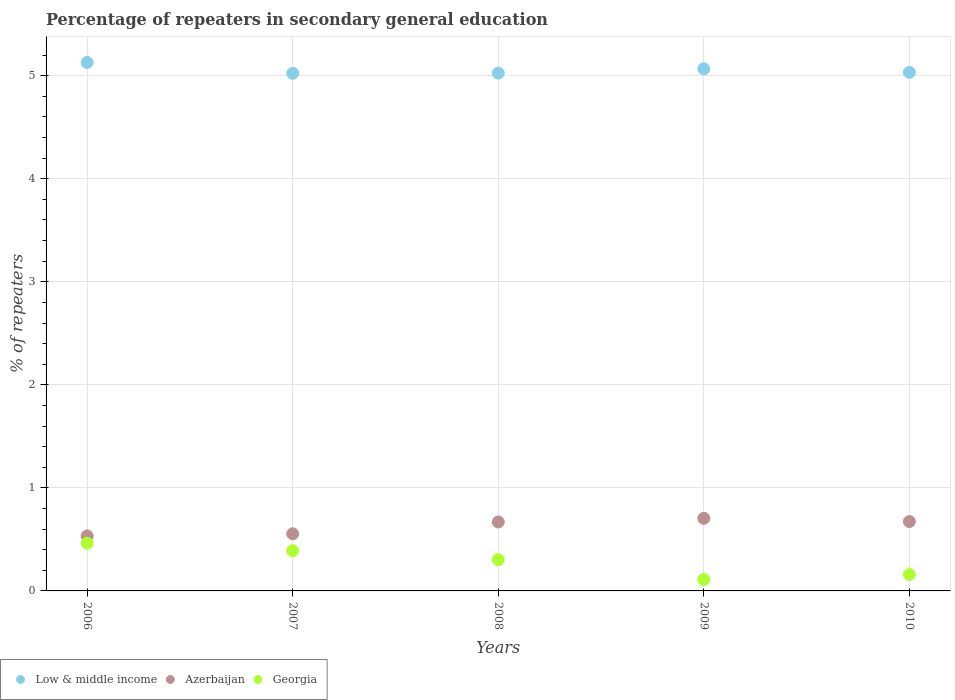How many different coloured dotlines are there?
Ensure brevity in your answer.  3. Is the number of dotlines equal to the number of legend labels?
Ensure brevity in your answer.  Yes. What is the percentage of repeaters in secondary general education in Azerbaijan in 2009?
Keep it short and to the point. 0.7. Across all years, what is the maximum percentage of repeaters in secondary general education in Georgia?
Your response must be concise. 0.46. Across all years, what is the minimum percentage of repeaters in secondary general education in Azerbaijan?
Give a very brief answer. 0.53. In which year was the percentage of repeaters in secondary general education in Georgia minimum?
Offer a very short reply. 2009. What is the total percentage of repeaters in secondary general education in Low & middle income in the graph?
Keep it short and to the point. 25.28. What is the difference between the percentage of repeaters in secondary general education in Low & middle income in 2007 and that in 2010?
Ensure brevity in your answer.  -0.01. What is the difference between the percentage of repeaters in secondary general education in Georgia in 2008 and the percentage of repeaters in secondary general education in Azerbaijan in 2007?
Your response must be concise. -0.25. What is the average percentage of repeaters in secondary general education in Low & middle income per year?
Provide a short and direct response. 5.06. In the year 2010, what is the difference between the percentage of repeaters in secondary general education in Georgia and percentage of repeaters in secondary general education in Azerbaijan?
Make the answer very short. -0.51. What is the ratio of the percentage of repeaters in secondary general education in Low & middle income in 2008 to that in 2010?
Keep it short and to the point. 1. Is the difference between the percentage of repeaters in secondary general education in Georgia in 2008 and 2009 greater than the difference between the percentage of repeaters in secondary general education in Azerbaijan in 2008 and 2009?
Make the answer very short. Yes. What is the difference between the highest and the second highest percentage of repeaters in secondary general education in Azerbaijan?
Ensure brevity in your answer.  0.03. What is the difference between the highest and the lowest percentage of repeaters in secondary general education in Georgia?
Your response must be concise. 0.35. In how many years, is the percentage of repeaters in secondary general education in Low & middle income greater than the average percentage of repeaters in secondary general education in Low & middle income taken over all years?
Give a very brief answer. 2. Is it the case that in every year, the sum of the percentage of repeaters in secondary general education in Azerbaijan and percentage of repeaters in secondary general education in Low & middle income  is greater than the percentage of repeaters in secondary general education in Georgia?
Your answer should be very brief. Yes. Does the percentage of repeaters in secondary general education in Azerbaijan monotonically increase over the years?
Provide a succinct answer. No. Is the percentage of repeaters in secondary general education in Georgia strictly less than the percentage of repeaters in secondary general education in Azerbaijan over the years?
Provide a succinct answer. Yes. How many dotlines are there?
Keep it short and to the point. 3. What is the difference between two consecutive major ticks on the Y-axis?
Offer a terse response. 1. Are the values on the major ticks of Y-axis written in scientific E-notation?
Ensure brevity in your answer.  No. Does the graph contain any zero values?
Offer a terse response. No. Where does the legend appear in the graph?
Give a very brief answer. Bottom left. How many legend labels are there?
Your answer should be compact. 3. What is the title of the graph?
Offer a terse response. Percentage of repeaters in secondary general education. What is the label or title of the X-axis?
Offer a very short reply. Years. What is the label or title of the Y-axis?
Offer a terse response. % of repeaters. What is the % of repeaters in Low & middle income in 2006?
Offer a very short reply. 5.13. What is the % of repeaters in Azerbaijan in 2006?
Your answer should be compact. 0.53. What is the % of repeaters of Georgia in 2006?
Offer a terse response. 0.46. What is the % of repeaters in Low & middle income in 2007?
Your answer should be compact. 5.02. What is the % of repeaters in Azerbaijan in 2007?
Offer a terse response. 0.55. What is the % of repeaters of Georgia in 2007?
Ensure brevity in your answer.  0.39. What is the % of repeaters in Low & middle income in 2008?
Your response must be concise. 5.02. What is the % of repeaters of Azerbaijan in 2008?
Give a very brief answer. 0.67. What is the % of repeaters in Georgia in 2008?
Your answer should be compact. 0.3. What is the % of repeaters in Low & middle income in 2009?
Ensure brevity in your answer.  5.07. What is the % of repeaters in Azerbaijan in 2009?
Make the answer very short. 0.7. What is the % of repeaters of Georgia in 2009?
Keep it short and to the point. 0.11. What is the % of repeaters of Low & middle income in 2010?
Give a very brief answer. 5.03. What is the % of repeaters of Azerbaijan in 2010?
Offer a very short reply. 0.67. What is the % of repeaters in Georgia in 2010?
Ensure brevity in your answer.  0.16. Across all years, what is the maximum % of repeaters of Low & middle income?
Offer a very short reply. 5.13. Across all years, what is the maximum % of repeaters of Azerbaijan?
Offer a very short reply. 0.7. Across all years, what is the maximum % of repeaters of Georgia?
Ensure brevity in your answer.  0.46. Across all years, what is the minimum % of repeaters of Low & middle income?
Offer a very short reply. 5.02. Across all years, what is the minimum % of repeaters of Azerbaijan?
Offer a terse response. 0.53. Across all years, what is the minimum % of repeaters in Georgia?
Give a very brief answer. 0.11. What is the total % of repeaters in Low & middle income in the graph?
Ensure brevity in your answer.  25.28. What is the total % of repeaters of Azerbaijan in the graph?
Ensure brevity in your answer.  3.14. What is the total % of repeaters of Georgia in the graph?
Your answer should be very brief. 1.43. What is the difference between the % of repeaters in Low & middle income in 2006 and that in 2007?
Your response must be concise. 0.11. What is the difference between the % of repeaters in Azerbaijan in 2006 and that in 2007?
Your answer should be compact. -0.02. What is the difference between the % of repeaters in Georgia in 2006 and that in 2007?
Make the answer very short. 0.07. What is the difference between the % of repeaters in Low & middle income in 2006 and that in 2008?
Provide a succinct answer. 0.1. What is the difference between the % of repeaters in Azerbaijan in 2006 and that in 2008?
Provide a short and direct response. -0.14. What is the difference between the % of repeaters in Georgia in 2006 and that in 2008?
Ensure brevity in your answer.  0.16. What is the difference between the % of repeaters in Low & middle income in 2006 and that in 2009?
Provide a short and direct response. 0.06. What is the difference between the % of repeaters of Azerbaijan in 2006 and that in 2009?
Offer a terse response. -0.17. What is the difference between the % of repeaters in Georgia in 2006 and that in 2009?
Make the answer very short. 0.35. What is the difference between the % of repeaters of Low & middle income in 2006 and that in 2010?
Make the answer very short. 0.1. What is the difference between the % of repeaters in Azerbaijan in 2006 and that in 2010?
Give a very brief answer. -0.14. What is the difference between the % of repeaters in Georgia in 2006 and that in 2010?
Offer a very short reply. 0.3. What is the difference between the % of repeaters in Low & middle income in 2007 and that in 2008?
Offer a terse response. -0. What is the difference between the % of repeaters of Azerbaijan in 2007 and that in 2008?
Your response must be concise. -0.11. What is the difference between the % of repeaters of Georgia in 2007 and that in 2008?
Offer a very short reply. 0.09. What is the difference between the % of repeaters of Low & middle income in 2007 and that in 2009?
Your answer should be compact. -0.04. What is the difference between the % of repeaters of Azerbaijan in 2007 and that in 2009?
Give a very brief answer. -0.15. What is the difference between the % of repeaters in Georgia in 2007 and that in 2009?
Provide a short and direct response. 0.28. What is the difference between the % of repeaters in Low & middle income in 2007 and that in 2010?
Offer a terse response. -0.01. What is the difference between the % of repeaters in Azerbaijan in 2007 and that in 2010?
Offer a terse response. -0.12. What is the difference between the % of repeaters in Georgia in 2007 and that in 2010?
Offer a terse response. 0.23. What is the difference between the % of repeaters of Low & middle income in 2008 and that in 2009?
Ensure brevity in your answer.  -0.04. What is the difference between the % of repeaters in Azerbaijan in 2008 and that in 2009?
Make the answer very short. -0.04. What is the difference between the % of repeaters of Georgia in 2008 and that in 2009?
Give a very brief answer. 0.19. What is the difference between the % of repeaters in Low & middle income in 2008 and that in 2010?
Offer a very short reply. -0.01. What is the difference between the % of repeaters of Azerbaijan in 2008 and that in 2010?
Provide a short and direct response. -0. What is the difference between the % of repeaters of Georgia in 2008 and that in 2010?
Provide a short and direct response. 0.14. What is the difference between the % of repeaters of Low & middle income in 2009 and that in 2010?
Offer a very short reply. 0.03. What is the difference between the % of repeaters of Azerbaijan in 2009 and that in 2010?
Offer a very short reply. 0.03. What is the difference between the % of repeaters of Georgia in 2009 and that in 2010?
Your answer should be compact. -0.05. What is the difference between the % of repeaters in Low & middle income in 2006 and the % of repeaters in Azerbaijan in 2007?
Provide a succinct answer. 4.57. What is the difference between the % of repeaters of Low & middle income in 2006 and the % of repeaters of Georgia in 2007?
Your answer should be compact. 4.74. What is the difference between the % of repeaters of Azerbaijan in 2006 and the % of repeaters of Georgia in 2007?
Your answer should be compact. 0.14. What is the difference between the % of repeaters in Low & middle income in 2006 and the % of repeaters in Azerbaijan in 2008?
Your answer should be very brief. 4.46. What is the difference between the % of repeaters of Low & middle income in 2006 and the % of repeaters of Georgia in 2008?
Offer a terse response. 4.83. What is the difference between the % of repeaters of Azerbaijan in 2006 and the % of repeaters of Georgia in 2008?
Your answer should be compact. 0.23. What is the difference between the % of repeaters of Low & middle income in 2006 and the % of repeaters of Azerbaijan in 2009?
Offer a terse response. 4.42. What is the difference between the % of repeaters of Low & middle income in 2006 and the % of repeaters of Georgia in 2009?
Give a very brief answer. 5.02. What is the difference between the % of repeaters in Azerbaijan in 2006 and the % of repeaters in Georgia in 2009?
Give a very brief answer. 0.42. What is the difference between the % of repeaters of Low & middle income in 2006 and the % of repeaters of Azerbaijan in 2010?
Keep it short and to the point. 4.46. What is the difference between the % of repeaters in Low & middle income in 2006 and the % of repeaters in Georgia in 2010?
Make the answer very short. 4.97. What is the difference between the % of repeaters in Azerbaijan in 2006 and the % of repeaters in Georgia in 2010?
Your answer should be compact. 0.37. What is the difference between the % of repeaters of Low & middle income in 2007 and the % of repeaters of Azerbaijan in 2008?
Make the answer very short. 4.35. What is the difference between the % of repeaters in Low & middle income in 2007 and the % of repeaters in Georgia in 2008?
Your answer should be compact. 4.72. What is the difference between the % of repeaters of Azerbaijan in 2007 and the % of repeaters of Georgia in 2008?
Keep it short and to the point. 0.25. What is the difference between the % of repeaters in Low & middle income in 2007 and the % of repeaters in Azerbaijan in 2009?
Your answer should be very brief. 4.32. What is the difference between the % of repeaters in Low & middle income in 2007 and the % of repeaters in Georgia in 2009?
Your answer should be compact. 4.91. What is the difference between the % of repeaters in Azerbaijan in 2007 and the % of repeaters in Georgia in 2009?
Your answer should be compact. 0.44. What is the difference between the % of repeaters of Low & middle income in 2007 and the % of repeaters of Azerbaijan in 2010?
Your answer should be very brief. 4.35. What is the difference between the % of repeaters in Low & middle income in 2007 and the % of repeaters in Georgia in 2010?
Your answer should be very brief. 4.86. What is the difference between the % of repeaters in Azerbaijan in 2007 and the % of repeaters in Georgia in 2010?
Keep it short and to the point. 0.4. What is the difference between the % of repeaters of Low & middle income in 2008 and the % of repeaters of Azerbaijan in 2009?
Keep it short and to the point. 4.32. What is the difference between the % of repeaters in Low & middle income in 2008 and the % of repeaters in Georgia in 2009?
Your answer should be very brief. 4.91. What is the difference between the % of repeaters of Azerbaijan in 2008 and the % of repeaters of Georgia in 2009?
Provide a short and direct response. 0.56. What is the difference between the % of repeaters in Low & middle income in 2008 and the % of repeaters in Azerbaijan in 2010?
Your answer should be compact. 4.35. What is the difference between the % of repeaters of Low & middle income in 2008 and the % of repeaters of Georgia in 2010?
Offer a terse response. 4.87. What is the difference between the % of repeaters of Azerbaijan in 2008 and the % of repeaters of Georgia in 2010?
Ensure brevity in your answer.  0.51. What is the difference between the % of repeaters of Low & middle income in 2009 and the % of repeaters of Azerbaijan in 2010?
Ensure brevity in your answer.  4.39. What is the difference between the % of repeaters in Low & middle income in 2009 and the % of repeaters in Georgia in 2010?
Give a very brief answer. 4.91. What is the difference between the % of repeaters of Azerbaijan in 2009 and the % of repeaters of Georgia in 2010?
Your answer should be very brief. 0.55. What is the average % of repeaters in Low & middle income per year?
Your answer should be compact. 5.06. What is the average % of repeaters of Azerbaijan per year?
Your answer should be compact. 0.63. What is the average % of repeaters of Georgia per year?
Offer a very short reply. 0.29. In the year 2006, what is the difference between the % of repeaters in Low & middle income and % of repeaters in Azerbaijan?
Keep it short and to the point. 4.6. In the year 2006, what is the difference between the % of repeaters of Low & middle income and % of repeaters of Georgia?
Provide a short and direct response. 4.67. In the year 2006, what is the difference between the % of repeaters of Azerbaijan and % of repeaters of Georgia?
Provide a succinct answer. 0.07. In the year 2007, what is the difference between the % of repeaters of Low & middle income and % of repeaters of Azerbaijan?
Make the answer very short. 4.47. In the year 2007, what is the difference between the % of repeaters in Low & middle income and % of repeaters in Georgia?
Your response must be concise. 4.63. In the year 2007, what is the difference between the % of repeaters in Azerbaijan and % of repeaters in Georgia?
Provide a succinct answer. 0.16. In the year 2008, what is the difference between the % of repeaters in Low & middle income and % of repeaters in Azerbaijan?
Give a very brief answer. 4.36. In the year 2008, what is the difference between the % of repeaters in Low & middle income and % of repeaters in Georgia?
Offer a very short reply. 4.72. In the year 2008, what is the difference between the % of repeaters in Azerbaijan and % of repeaters in Georgia?
Make the answer very short. 0.37. In the year 2009, what is the difference between the % of repeaters in Low & middle income and % of repeaters in Azerbaijan?
Keep it short and to the point. 4.36. In the year 2009, what is the difference between the % of repeaters in Low & middle income and % of repeaters in Georgia?
Ensure brevity in your answer.  4.96. In the year 2009, what is the difference between the % of repeaters in Azerbaijan and % of repeaters in Georgia?
Your answer should be compact. 0.59. In the year 2010, what is the difference between the % of repeaters of Low & middle income and % of repeaters of Azerbaijan?
Your response must be concise. 4.36. In the year 2010, what is the difference between the % of repeaters of Low & middle income and % of repeaters of Georgia?
Keep it short and to the point. 4.87. In the year 2010, what is the difference between the % of repeaters of Azerbaijan and % of repeaters of Georgia?
Your answer should be compact. 0.51. What is the ratio of the % of repeaters of Low & middle income in 2006 to that in 2007?
Ensure brevity in your answer.  1.02. What is the ratio of the % of repeaters of Azerbaijan in 2006 to that in 2007?
Provide a succinct answer. 0.96. What is the ratio of the % of repeaters in Georgia in 2006 to that in 2007?
Offer a terse response. 1.18. What is the ratio of the % of repeaters in Low & middle income in 2006 to that in 2008?
Your response must be concise. 1.02. What is the ratio of the % of repeaters in Azerbaijan in 2006 to that in 2008?
Keep it short and to the point. 0.8. What is the ratio of the % of repeaters of Georgia in 2006 to that in 2008?
Ensure brevity in your answer.  1.52. What is the ratio of the % of repeaters in Low & middle income in 2006 to that in 2009?
Keep it short and to the point. 1.01. What is the ratio of the % of repeaters in Azerbaijan in 2006 to that in 2009?
Your answer should be very brief. 0.76. What is the ratio of the % of repeaters of Georgia in 2006 to that in 2009?
Ensure brevity in your answer.  4.18. What is the ratio of the % of repeaters in Low & middle income in 2006 to that in 2010?
Offer a terse response. 1.02. What is the ratio of the % of repeaters of Azerbaijan in 2006 to that in 2010?
Offer a very short reply. 0.79. What is the ratio of the % of repeaters of Georgia in 2006 to that in 2010?
Offer a very short reply. 2.91. What is the ratio of the % of repeaters in Azerbaijan in 2007 to that in 2008?
Ensure brevity in your answer.  0.83. What is the ratio of the % of repeaters in Georgia in 2007 to that in 2008?
Offer a terse response. 1.29. What is the ratio of the % of repeaters in Low & middle income in 2007 to that in 2009?
Keep it short and to the point. 0.99. What is the ratio of the % of repeaters in Azerbaijan in 2007 to that in 2009?
Your answer should be very brief. 0.79. What is the ratio of the % of repeaters in Georgia in 2007 to that in 2009?
Give a very brief answer. 3.53. What is the ratio of the % of repeaters in Azerbaijan in 2007 to that in 2010?
Make the answer very short. 0.82. What is the ratio of the % of repeaters in Georgia in 2007 to that in 2010?
Keep it short and to the point. 2.46. What is the ratio of the % of repeaters of Low & middle income in 2008 to that in 2009?
Your response must be concise. 0.99. What is the ratio of the % of repeaters of Azerbaijan in 2008 to that in 2009?
Offer a very short reply. 0.95. What is the ratio of the % of repeaters of Georgia in 2008 to that in 2009?
Your response must be concise. 2.74. What is the ratio of the % of repeaters of Azerbaijan in 2008 to that in 2010?
Provide a succinct answer. 0.99. What is the ratio of the % of repeaters of Georgia in 2008 to that in 2010?
Ensure brevity in your answer.  1.91. What is the ratio of the % of repeaters in Low & middle income in 2009 to that in 2010?
Give a very brief answer. 1.01. What is the ratio of the % of repeaters in Azerbaijan in 2009 to that in 2010?
Ensure brevity in your answer.  1.05. What is the ratio of the % of repeaters in Georgia in 2009 to that in 2010?
Keep it short and to the point. 0.7. What is the difference between the highest and the second highest % of repeaters of Low & middle income?
Offer a very short reply. 0.06. What is the difference between the highest and the second highest % of repeaters of Azerbaijan?
Provide a succinct answer. 0.03. What is the difference between the highest and the second highest % of repeaters in Georgia?
Make the answer very short. 0.07. What is the difference between the highest and the lowest % of repeaters of Low & middle income?
Keep it short and to the point. 0.11. What is the difference between the highest and the lowest % of repeaters of Azerbaijan?
Provide a succinct answer. 0.17. What is the difference between the highest and the lowest % of repeaters of Georgia?
Give a very brief answer. 0.35. 